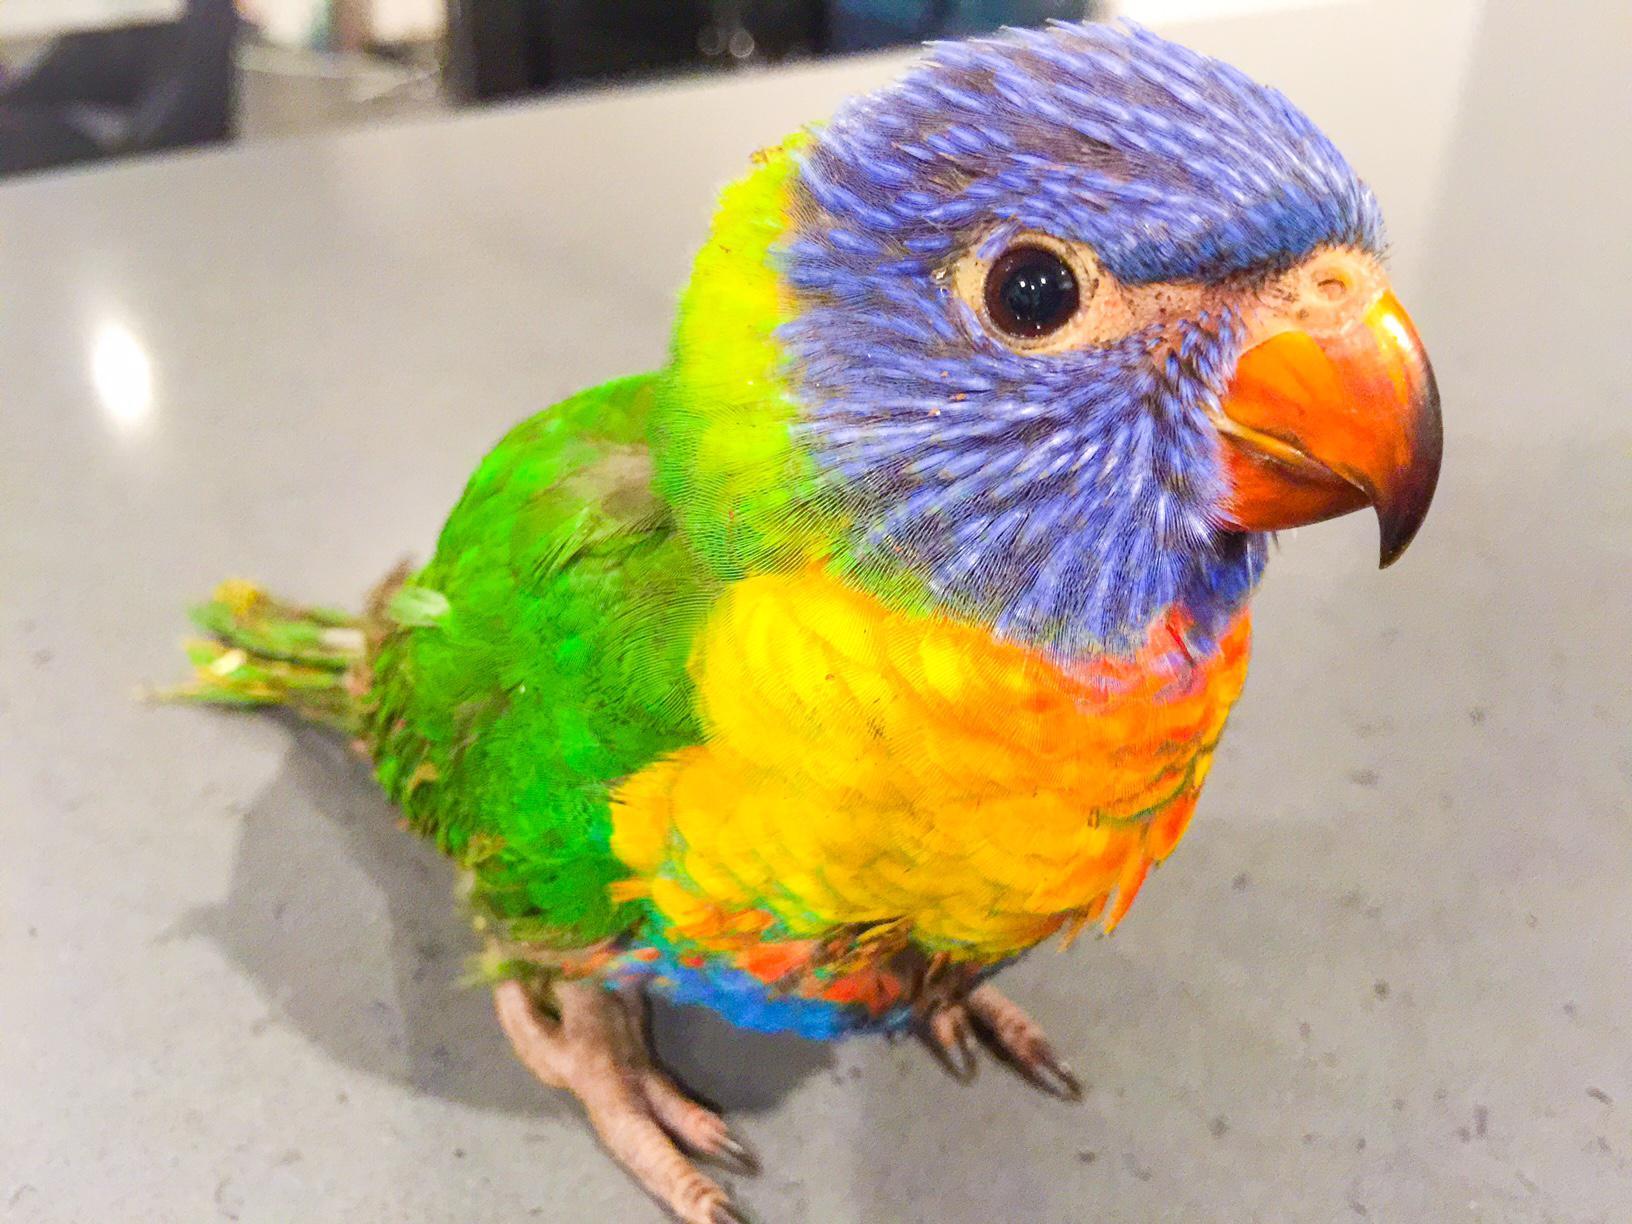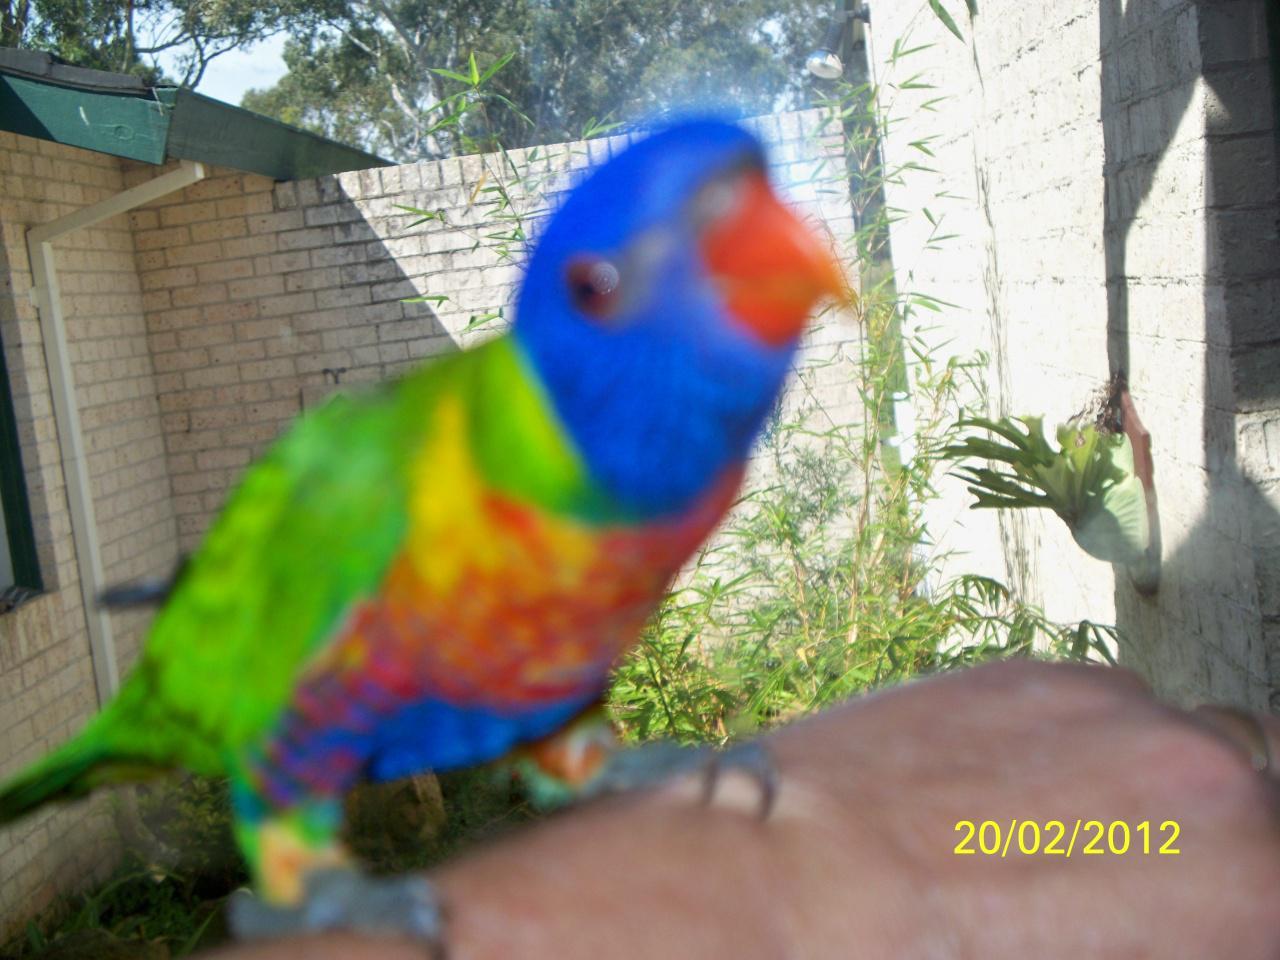The first image is the image on the left, the second image is the image on the right. Analyze the images presented: Is the assertion "In one of the images there are two colorful birds standing next to each other." valid? Answer yes or no. No. The first image is the image on the left, the second image is the image on the right. Analyze the images presented: Is the assertion "One image features two multicolored parrots side-by-side." valid? Answer yes or no. No. 